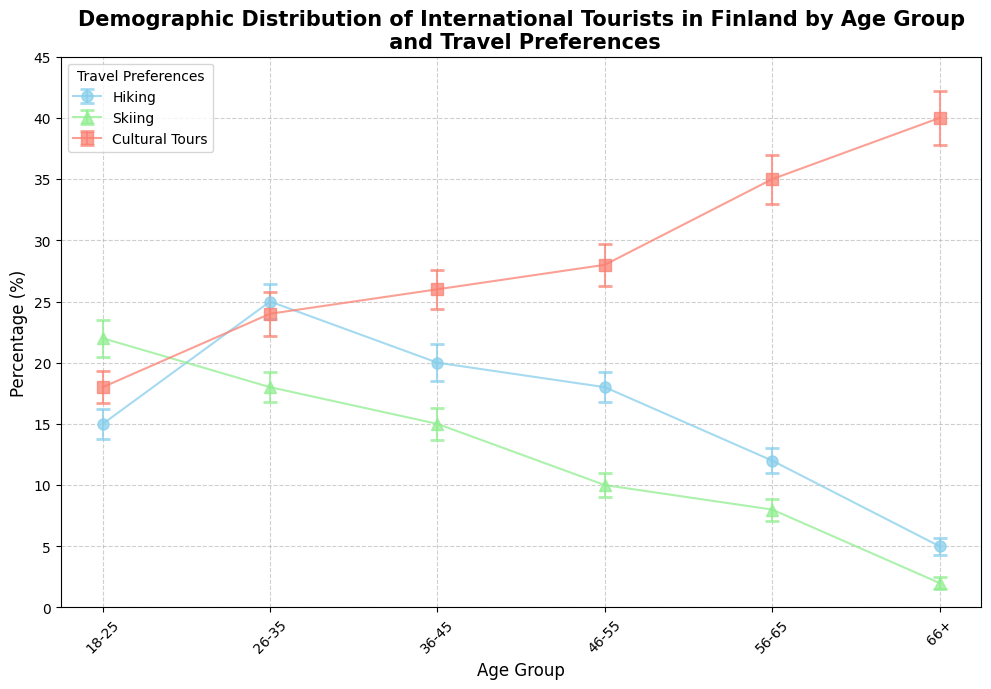What travel preference is most popular among tourists aged 66+? The chart shows the percentage distribution of travel preferences by age group. For the 66+ age group, the percentage of tourists who prefer cultural tours is the highest at 40%.
Answer: Cultural Tours Which age group has the highest percentage of tourists who prefer hiking? Looking at the hiking percentages across different age groups, the 26-35 age group has the highest percentage at 25%.
Answer: 26-35 Which travel preference has the highest error margin for the 56-65 age group? The error margins for the 56-65 age group are 1.0 for hiking, 0.9 for skiing, and 2.0 for cultural tours. The highest error margin is for cultural tours.
Answer: Cultural Tours How does the percentage of tourists who prefer skiing in the 46-55 age group compare to those in the 26-35 age group? The percentage of tourists who prefer skiing in the 46-55 age group is 10%, whereas it is 18% in the 26-35 age group. Thus, the preference is higher in the 26-35 age group.
Answer: Higher in 26-35 What is the difference in the percentage of tourists who prefer cultural tours between the 18-25 and the 66+ age groups? The percentage of tourists who prefer cultural tours is 18% for the 18-25 age group and 40% for the 66+ age group. The difference is 40% - 18% = 22%.
Answer: 22% By how much do the percentages of tourists who prefer hiking and skiing differ in the 36-45 age group? In the 36-45 age group, the percentage for hiking is 20%, and for skiing it is 15%. The difference is 20% - 15% = 5%.
Answer: 5% Which travel preference shows the most consistent error margin across all age groups? Comparing the error margins for all travel preferences across age groups, skiing has lower variations (ranging from 0.5 to 1.5) compared to hiking and cultural tours.
Answer: Skiing In which age group is the preference for cultural tours closest to the preference for hiking? For the age group 26-35, the percentage of tourists who prefer cultural tours is 24% and those who prefer hiking is 25%. The difference is only 1%.
Answer: 26-35 Which age group has the smallest percentage of tourists who prefer skiing, and what is that percentage? The 66+ age group has the smallest percentage of tourists who prefer skiing at 2%.
Answer: 66+, 2% 